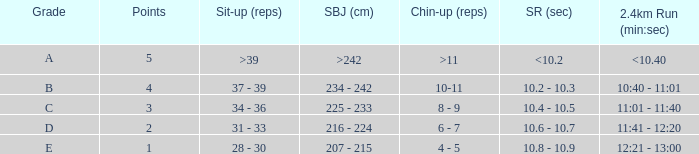Tell me the 2.4km run for points less than 2 12:21 - 13:00. 